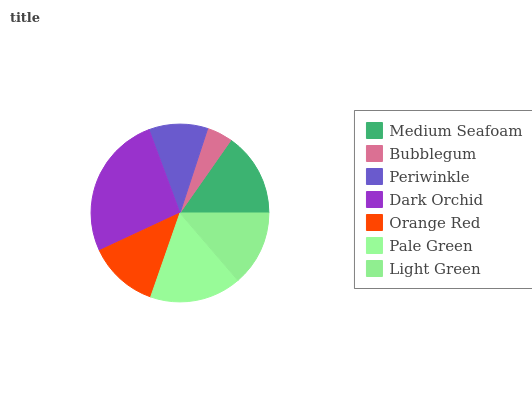Is Bubblegum the minimum?
Answer yes or no. Yes. Is Dark Orchid the maximum?
Answer yes or no. Yes. Is Periwinkle the minimum?
Answer yes or no. No. Is Periwinkle the maximum?
Answer yes or no. No. Is Periwinkle greater than Bubblegum?
Answer yes or no. Yes. Is Bubblegum less than Periwinkle?
Answer yes or no. Yes. Is Bubblegum greater than Periwinkle?
Answer yes or no. No. Is Periwinkle less than Bubblegum?
Answer yes or no. No. Is Light Green the high median?
Answer yes or no. Yes. Is Light Green the low median?
Answer yes or no. Yes. Is Periwinkle the high median?
Answer yes or no. No. Is Bubblegum the low median?
Answer yes or no. No. 